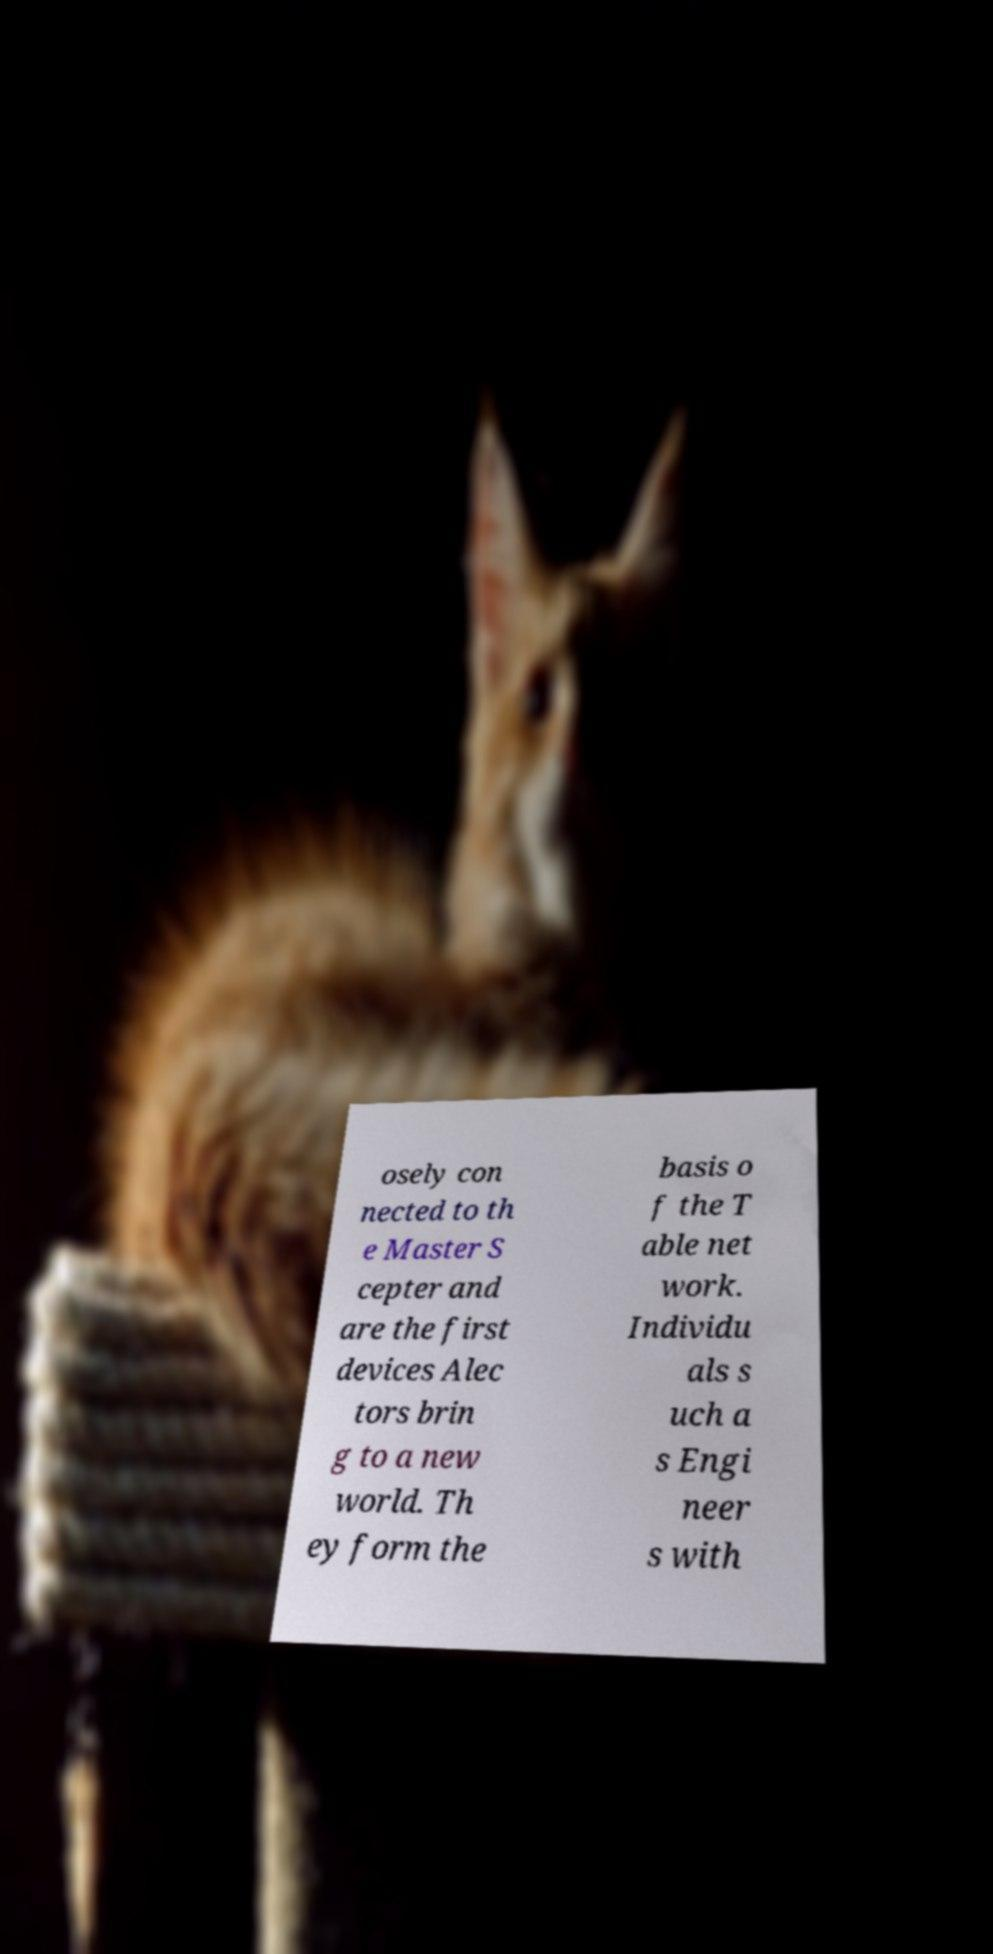I need the written content from this picture converted into text. Can you do that? osely con nected to th e Master S cepter and are the first devices Alec tors brin g to a new world. Th ey form the basis o f the T able net work. Individu als s uch a s Engi neer s with 